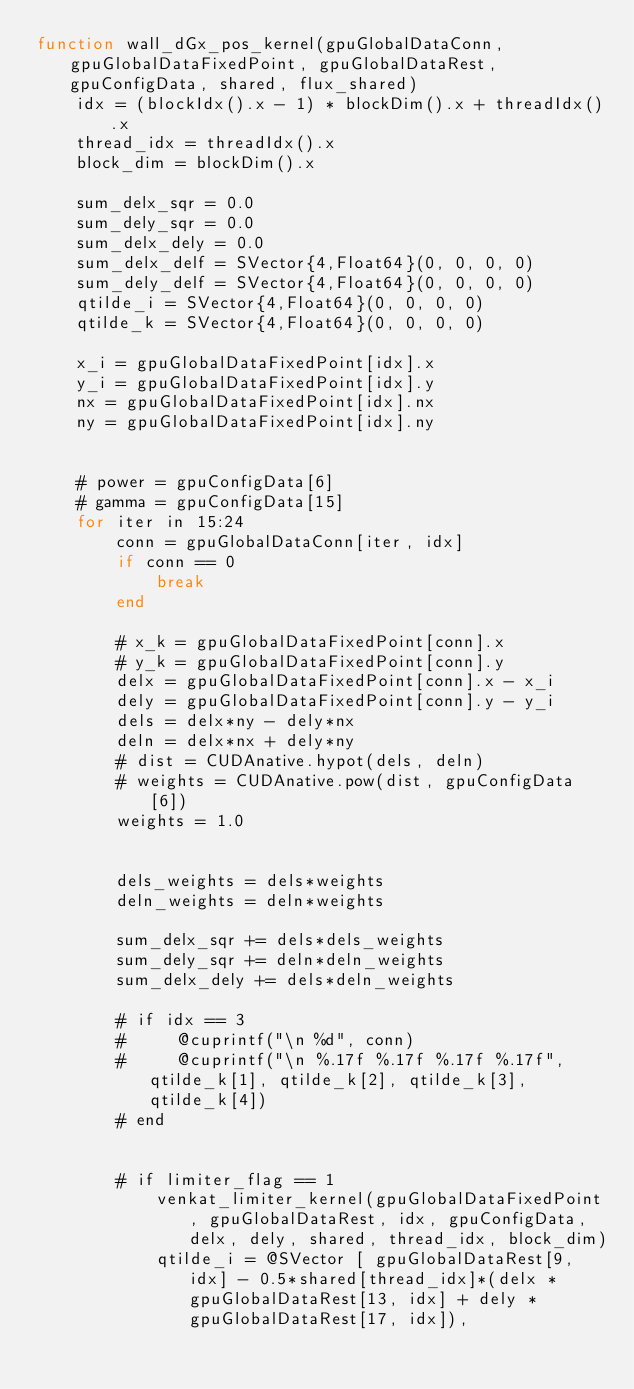<code> <loc_0><loc_0><loc_500><loc_500><_Julia_>function wall_dGx_pos_kernel(gpuGlobalDataConn, gpuGlobalDataFixedPoint, gpuGlobalDataRest, gpuConfigData, shared, flux_shared)
    idx = (blockIdx().x - 1) * blockDim().x + threadIdx().x
    thread_idx = threadIdx().x
    block_dim = blockDim().x

    sum_delx_sqr = 0.0
    sum_dely_sqr = 0.0
    sum_delx_dely = 0.0
    sum_delx_delf = SVector{4,Float64}(0, 0, 0, 0)
    sum_dely_delf = SVector{4,Float64}(0, 0, 0, 0)
    qtilde_i = SVector{4,Float64}(0, 0, 0, 0)
    qtilde_k = SVector{4,Float64}(0, 0, 0, 0)

    x_i = gpuGlobalDataFixedPoint[idx].x
    y_i = gpuGlobalDataFixedPoint[idx].y
    nx = gpuGlobalDataFixedPoint[idx].nx
    ny = gpuGlobalDataFixedPoint[idx].ny


    # power = gpuConfigData[6]
    # gamma = gpuConfigData[15]
    for iter in 15:24
        conn = gpuGlobalDataConn[iter, idx]
        if conn == 0
            break
        end

        # x_k = gpuGlobalDataFixedPoint[conn].x
        # y_k = gpuGlobalDataFixedPoint[conn].y
        delx = gpuGlobalDataFixedPoint[conn].x - x_i
        dely = gpuGlobalDataFixedPoint[conn].y - y_i
        dels = delx*ny - dely*nx
        deln = delx*nx + dely*ny
        # dist = CUDAnative.hypot(dels, deln)
        # weights = CUDAnative.pow(dist, gpuConfigData[6])
        weights = 1.0


        dels_weights = dels*weights
        deln_weights = deln*weights

        sum_delx_sqr += dels*dels_weights
        sum_dely_sqr += deln*deln_weights
        sum_delx_dely += dels*deln_weights

        # if idx == 3
        #     @cuprintf("\n %d", conn)
        #     @cuprintf("\n %.17f %.17f %.17f %.17f", qtilde_k[1], qtilde_k[2], qtilde_k[3], qtilde_k[4])
        # end


        # if limiter_flag == 1
            venkat_limiter_kernel(gpuGlobalDataFixedPoint, gpuGlobalDataRest, idx, gpuConfigData, delx, dely, shared, thread_idx, block_dim)
            qtilde_i = @SVector [ gpuGlobalDataRest[9, idx] - 0.5*shared[thread_idx]*(delx * gpuGlobalDataRest[13, idx] + dely * gpuGlobalDataRest[17, idx]),</code> 